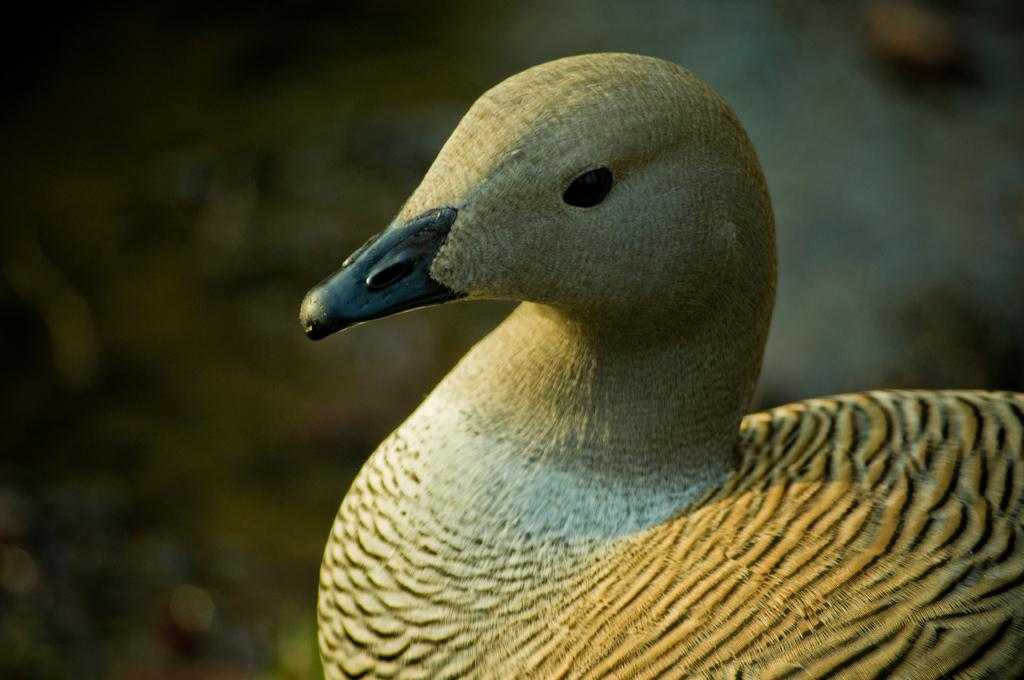What is the main subject in the foreground of the image? There is a bird in the foreground of the image. What type of natural environment can be seen in the background of the image? There is grass visible in the background of the image. How does the bird express its pain in the image? There is no indication of pain in the image; the bird appears to be in a natural environment. 